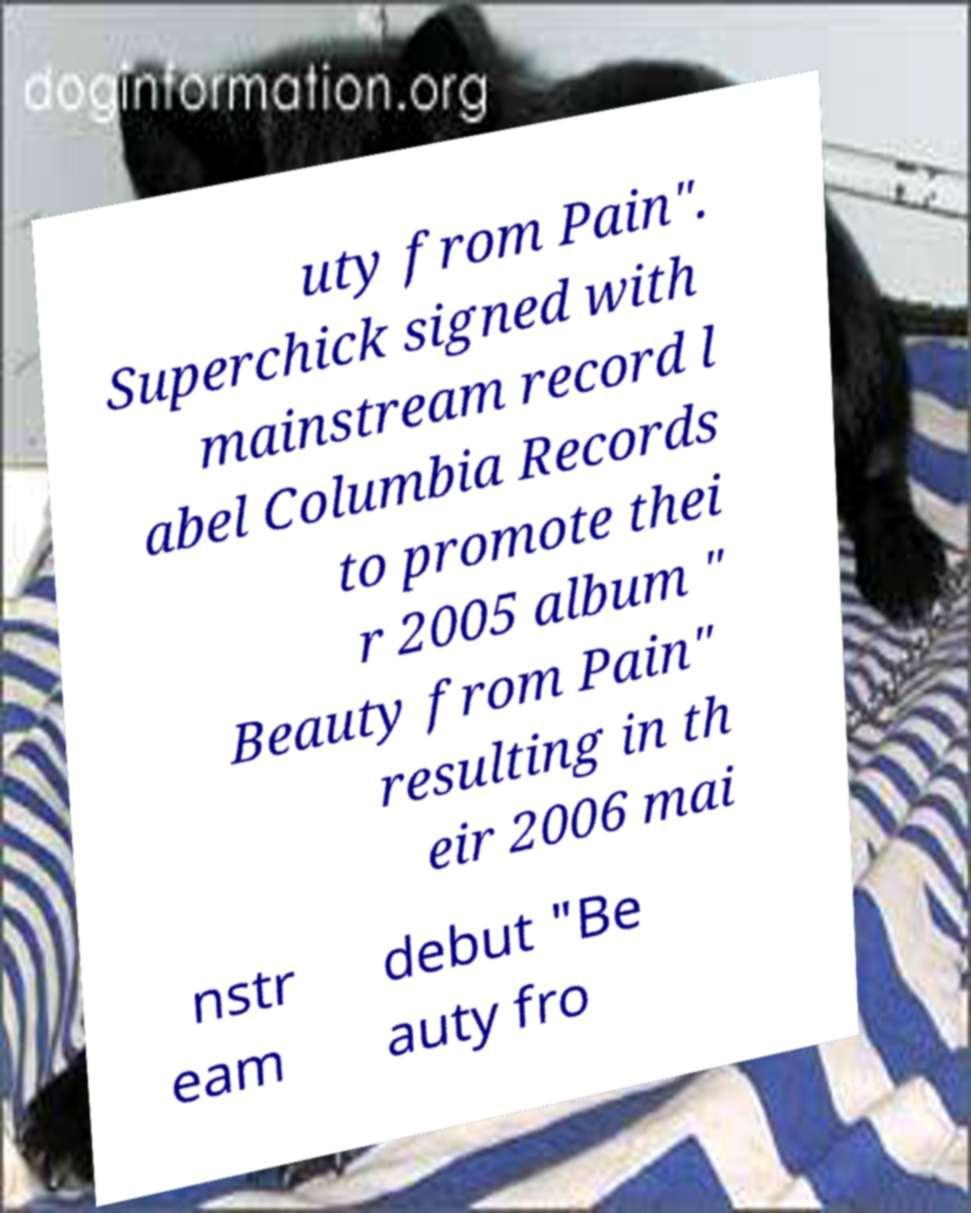Please read and relay the text visible in this image. What does it say? uty from Pain". Superchick signed with mainstream record l abel Columbia Records to promote thei r 2005 album " Beauty from Pain" resulting in th eir 2006 mai nstr eam debut "Be auty fro 